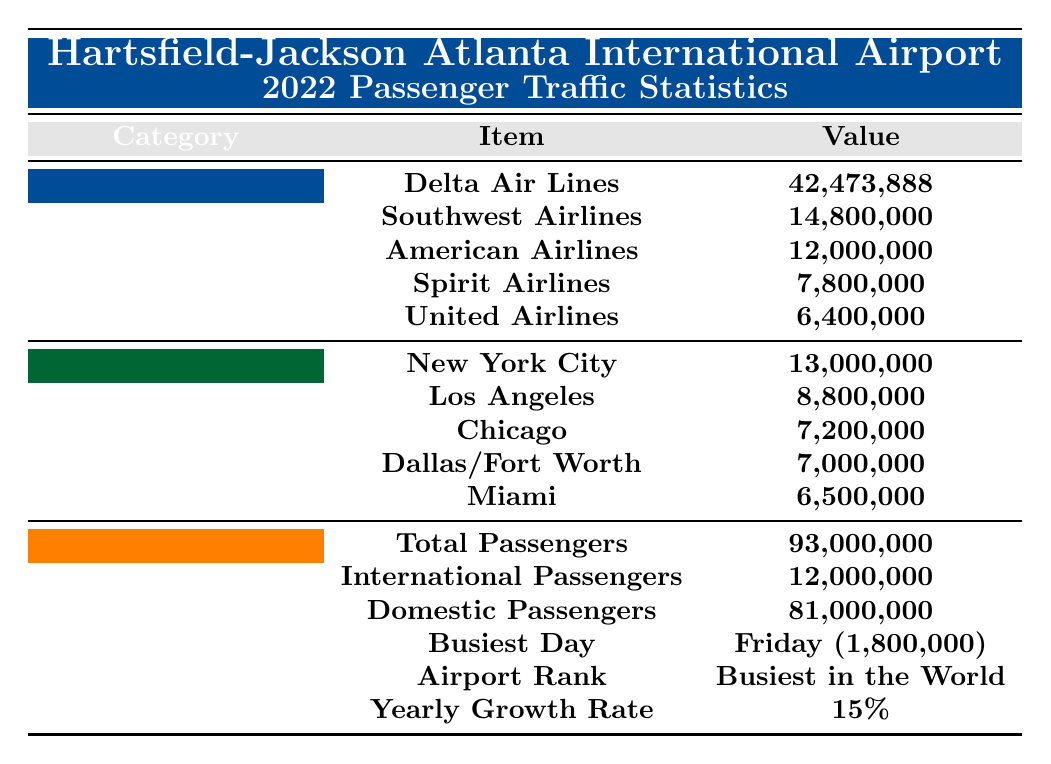What is the total number of passengers in 2022? The table specifies the total passengers under the "Key Facts" section, which states it is 93,000,000.
Answer: 93,000,000 Which airline had the highest number of passengers? Looking at the "Top 5 Airlines" section of the table, Delta Air Lines has the highest number of passengers at 42,473,888.
Answer: Delta Air Lines How many passengers flew with Southwest Airlines? The table shows that Southwest Airlines carried 14,800,000 passengers in 2022 in the "Top 5 Airlines" section.
Answer: 14,800,000 What percentage of the total passengers were international? The table indicates that there were 12,000,000 international passengers. To find the percentage, calculate (12,000,000 / 93,000,000) * 100, which is approximately 12.9%.
Answer: Approximately 12.9% What is the difference in passenger numbers between Delta Air Lines and American Airlines? From the table, Delta Air Lines had 42,473,888 passengers and American Airlines had 12,000,000 passengers. The difference is 42,473,888 - 12,000,000 = 30,473,888.
Answer: 30,473,888 Which destination had the least number of passengers? In the "Top 5 Destinations," Miami has the least number of passengers, with 6,500,000.
Answer: Miami On which day did the airport experience the highest passenger traffic? Referring to the "Key Facts" under "Most Popular Days," Friday is listed as the day with the highest passenger count at 1,800,000.
Answer: Friday How many more domestic passengers were there than international passengers? The table specifies there were 81,000,000 domestic passengers and 12,000,000 international passengers. The difference is 81,000,000 - 12,000,000 = 69,000,000.
Answer: 69,000,000 What was the total passenger count for the top two destinations? From the "Top 5 Destinations" section, New York City had 13,000,000 passengers and Los Angeles had 8,800,000. Summing these gives 13,000,000 + 8,800,000 = 21,800,000.
Answer: 21,800,000 Is it true that the airport's yearly growth rate was 15%? The table states that the yearly growth rate is indeed 15%, so the statement is true.
Answer: True 